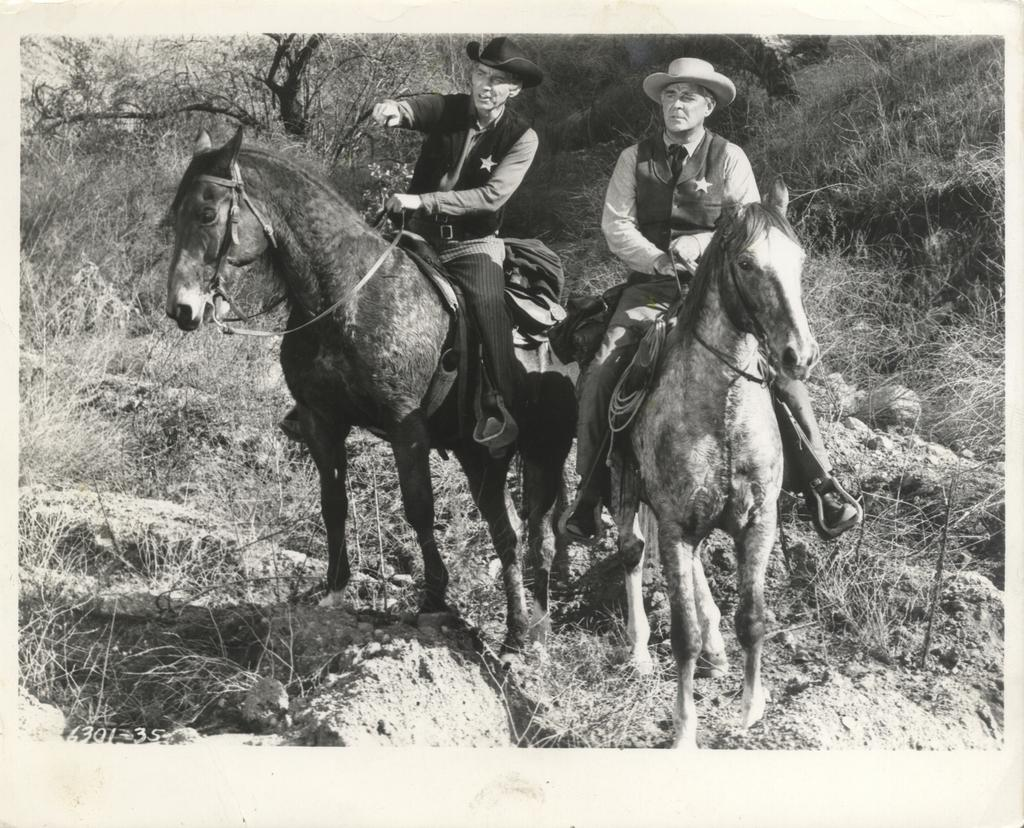How many people are in the image? There are two people in the image. What are the people doing in the image? The people are sitting on horses. What are the people wearing on their heads? The people are wearing hats. What can be seen in the background of the image? There are trees in the background of the image. What type of seed is being planted by the people in the image? There is no seed or planting activity depicted in the image; the people are sitting on horses and wearing hats. What answer is being given by the rake in the image? There is no rake or any object capable of giving an answer present in the image. 